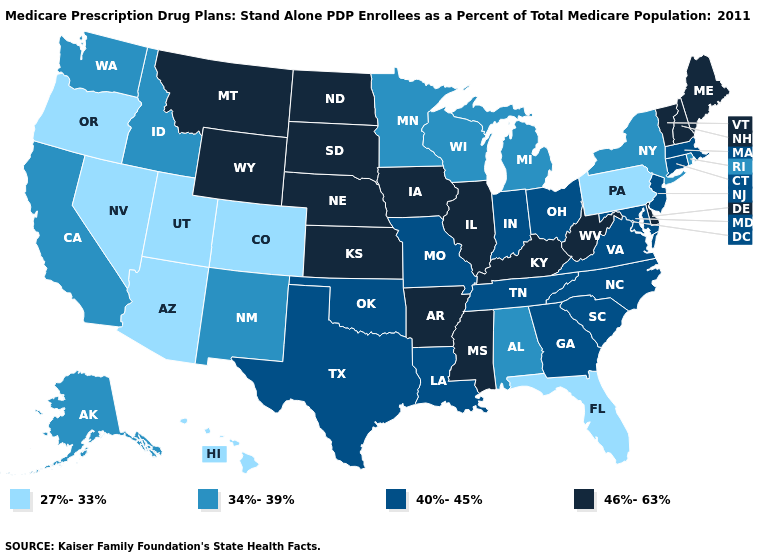Name the states that have a value in the range 27%-33%?
Quick response, please. Arizona, Colorado, Florida, Hawaii, Nevada, Oregon, Pennsylvania, Utah. Name the states that have a value in the range 46%-63%?
Be succinct. Arkansas, Delaware, Iowa, Illinois, Kansas, Kentucky, Maine, Mississippi, Montana, North Dakota, Nebraska, New Hampshire, South Dakota, Vermont, West Virginia, Wyoming. What is the highest value in the USA?
Answer briefly. 46%-63%. How many symbols are there in the legend?
Be succinct. 4. Does Pennsylvania have the lowest value in the Northeast?
Be succinct. Yes. Does the first symbol in the legend represent the smallest category?
Keep it brief. Yes. Name the states that have a value in the range 40%-45%?
Write a very short answer. Connecticut, Georgia, Indiana, Louisiana, Massachusetts, Maryland, Missouri, North Carolina, New Jersey, Ohio, Oklahoma, South Carolina, Tennessee, Texas, Virginia. Which states have the highest value in the USA?
Write a very short answer. Arkansas, Delaware, Iowa, Illinois, Kansas, Kentucky, Maine, Mississippi, Montana, North Dakota, Nebraska, New Hampshire, South Dakota, Vermont, West Virginia, Wyoming. What is the value of Oklahoma?
Keep it brief. 40%-45%. Does Alabama have the highest value in the South?
Quick response, please. No. Does Vermont have the highest value in the USA?
Quick response, please. Yes. How many symbols are there in the legend?
Quick response, please. 4. Does the first symbol in the legend represent the smallest category?
Concise answer only. Yes. Among the states that border Maine , which have the highest value?
Give a very brief answer. New Hampshire. Does Indiana have the highest value in the USA?
Keep it brief. No. 